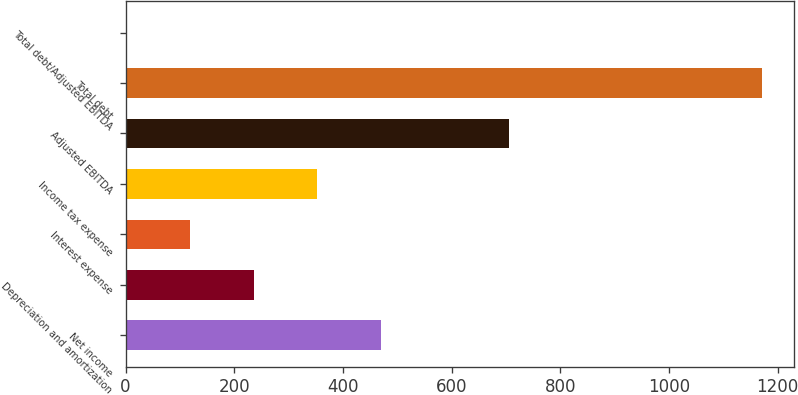<chart> <loc_0><loc_0><loc_500><loc_500><bar_chart><fcel>Net income<fcel>Depreciation and amortization<fcel>Interest expense<fcel>Income tax expense<fcel>Adjusted EBITDA<fcel>Total debt<fcel>Total debt/Adjusted EBITDA<nl><fcel>469.7<fcel>235.68<fcel>118.67<fcel>352.69<fcel>705<fcel>1171.8<fcel>1.66<nl></chart> 